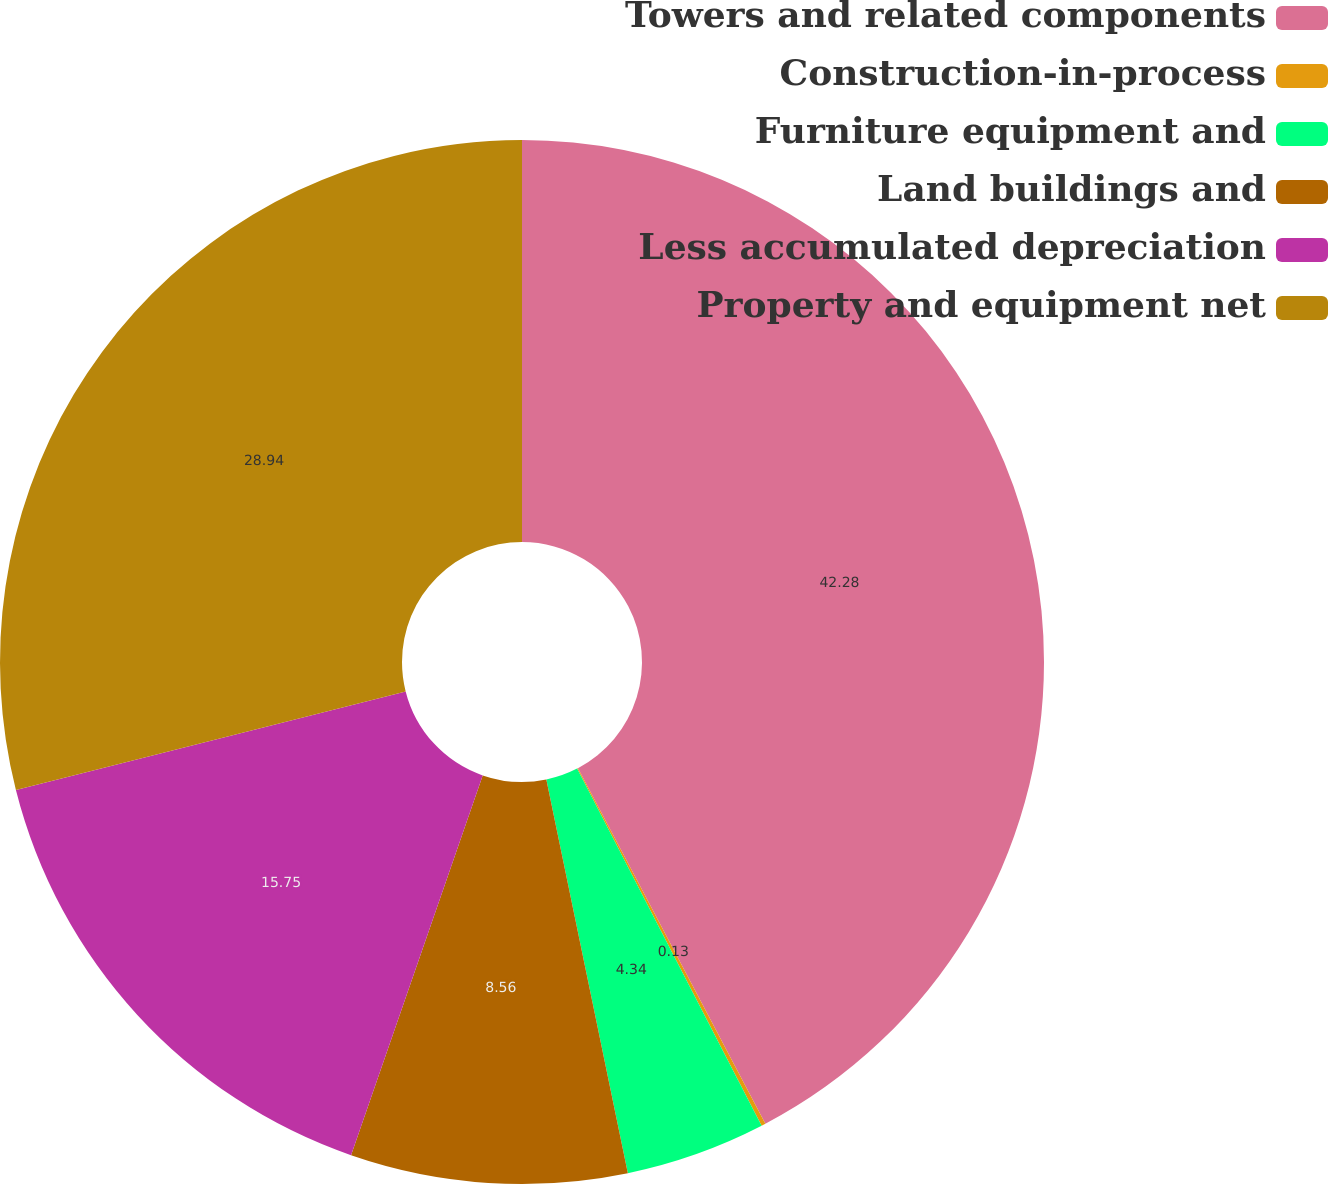Convert chart. <chart><loc_0><loc_0><loc_500><loc_500><pie_chart><fcel>Towers and related components<fcel>Construction-in-process<fcel>Furniture equipment and<fcel>Land buildings and<fcel>Less accumulated depreciation<fcel>Property and equipment net<nl><fcel>42.28%<fcel>0.13%<fcel>4.34%<fcel>8.56%<fcel>15.75%<fcel>28.94%<nl></chart> 